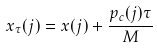Convert formula to latex. <formula><loc_0><loc_0><loc_500><loc_500>x _ { \tau } ( j ) = x ( j ) + \frac { p _ { c } ( j ) \tau } { M }</formula> 